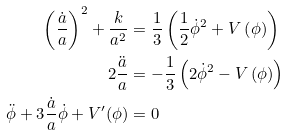Convert formula to latex. <formula><loc_0><loc_0><loc_500><loc_500>\left ( \frac { \dot { a } } { a } \right ) ^ { 2 } + \frac { k } { a ^ { 2 } } & = \frac { 1 } { 3 } \left ( \frac { 1 } { 2 } \dot { \phi } ^ { 2 } + V \left ( \phi \right ) \right ) \\ 2 \frac { \ddot { a } } { a } & = - \frac { 1 } { 3 } \left ( 2 \dot { \phi } ^ { 2 } - V \left ( \phi \right ) \right ) \\ \ddot { \phi } + 3 \frac { \dot { a } } { a } \dot { \phi } + V ^ { \prime } ( \phi ) & = 0</formula> 